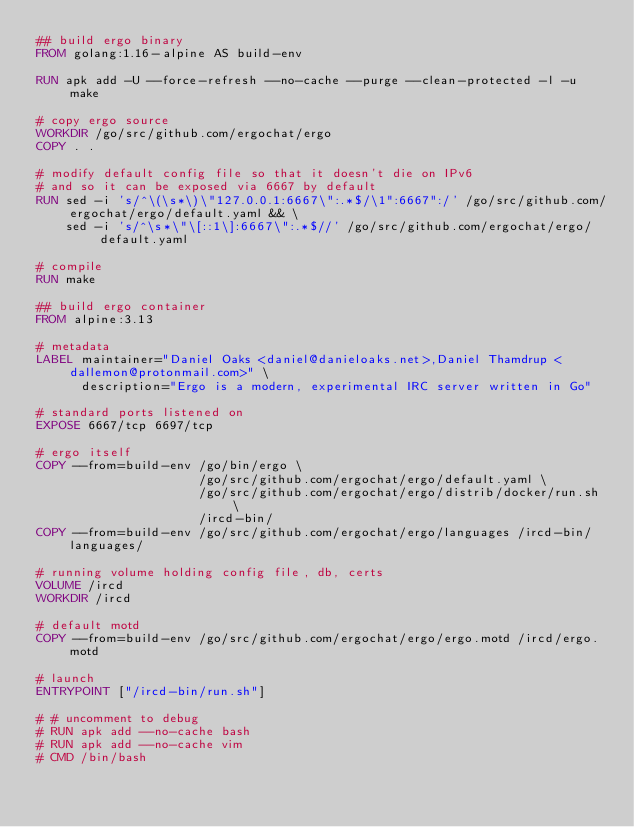<code> <loc_0><loc_0><loc_500><loc_500><_Dockerfile_>## build ergo binary
FROM golang:1.16-alpine AS build-env

RUN apk add -U --force-refresh --no-cache --purge --clean-protected -l -u make

# copy ergo source
WORKDIR /go/src/github.com/ergochat/ergo
COPY . .

# modify default config file so that it doesn't die on IPv6
# and so it can be exposed via 6667 by default
RUN sed -i 's/^\(\s*\)\"127.0.0.1:6667\":.*$/\1":6667":/' /go/src/github.com/ergochat/ergo/default.yaml && \
    sed -i 's/^\s*\"\[::1\]:6667\":.*$//' /go/src/github.com/ergochat/ergo/default.yaml

# compile
RUN make

## build ergo container
FROM alpine:3.13

# metadata
LABEL maintainer="Daniel Oaks <daniel@danieloaks.net>,Daniel Thamdrup <dallemon@protonmail.com>" \
      description="Ergo is a modern, experimental IRC server written in Go"

# standard ports listened on
EXPOSE 6667/tcp 6697/tcp

# ergo itself
COPY --from=build-env /go/bin/ergo \
                      /go/src/github.com/ergochat/ergo/default.yaml \
                      /go/src/github.com/ergochat/ergo/distrib/docker/run.sh \
                      /ircd-bin/
COPY --from=build-env /go/src/github.com/ergochat/ergo/languages /ircd-bin/languages/

# running volume holding config file, db, certs
VOLUME /ircd
WORKDIR /ircd

# default motd
COPY --from=build-env /go/src/github.com/ergochat/ergo/ergo.motd /ircd/ergo.motd

# launch
ENTRYPOINT ["/ircd-bin/run.sh"]

# # uncomment to debug
# RUN apk add --no-cache bash
# RUN apk add --no-cache vim
# CMD /bin/bash
</code> 